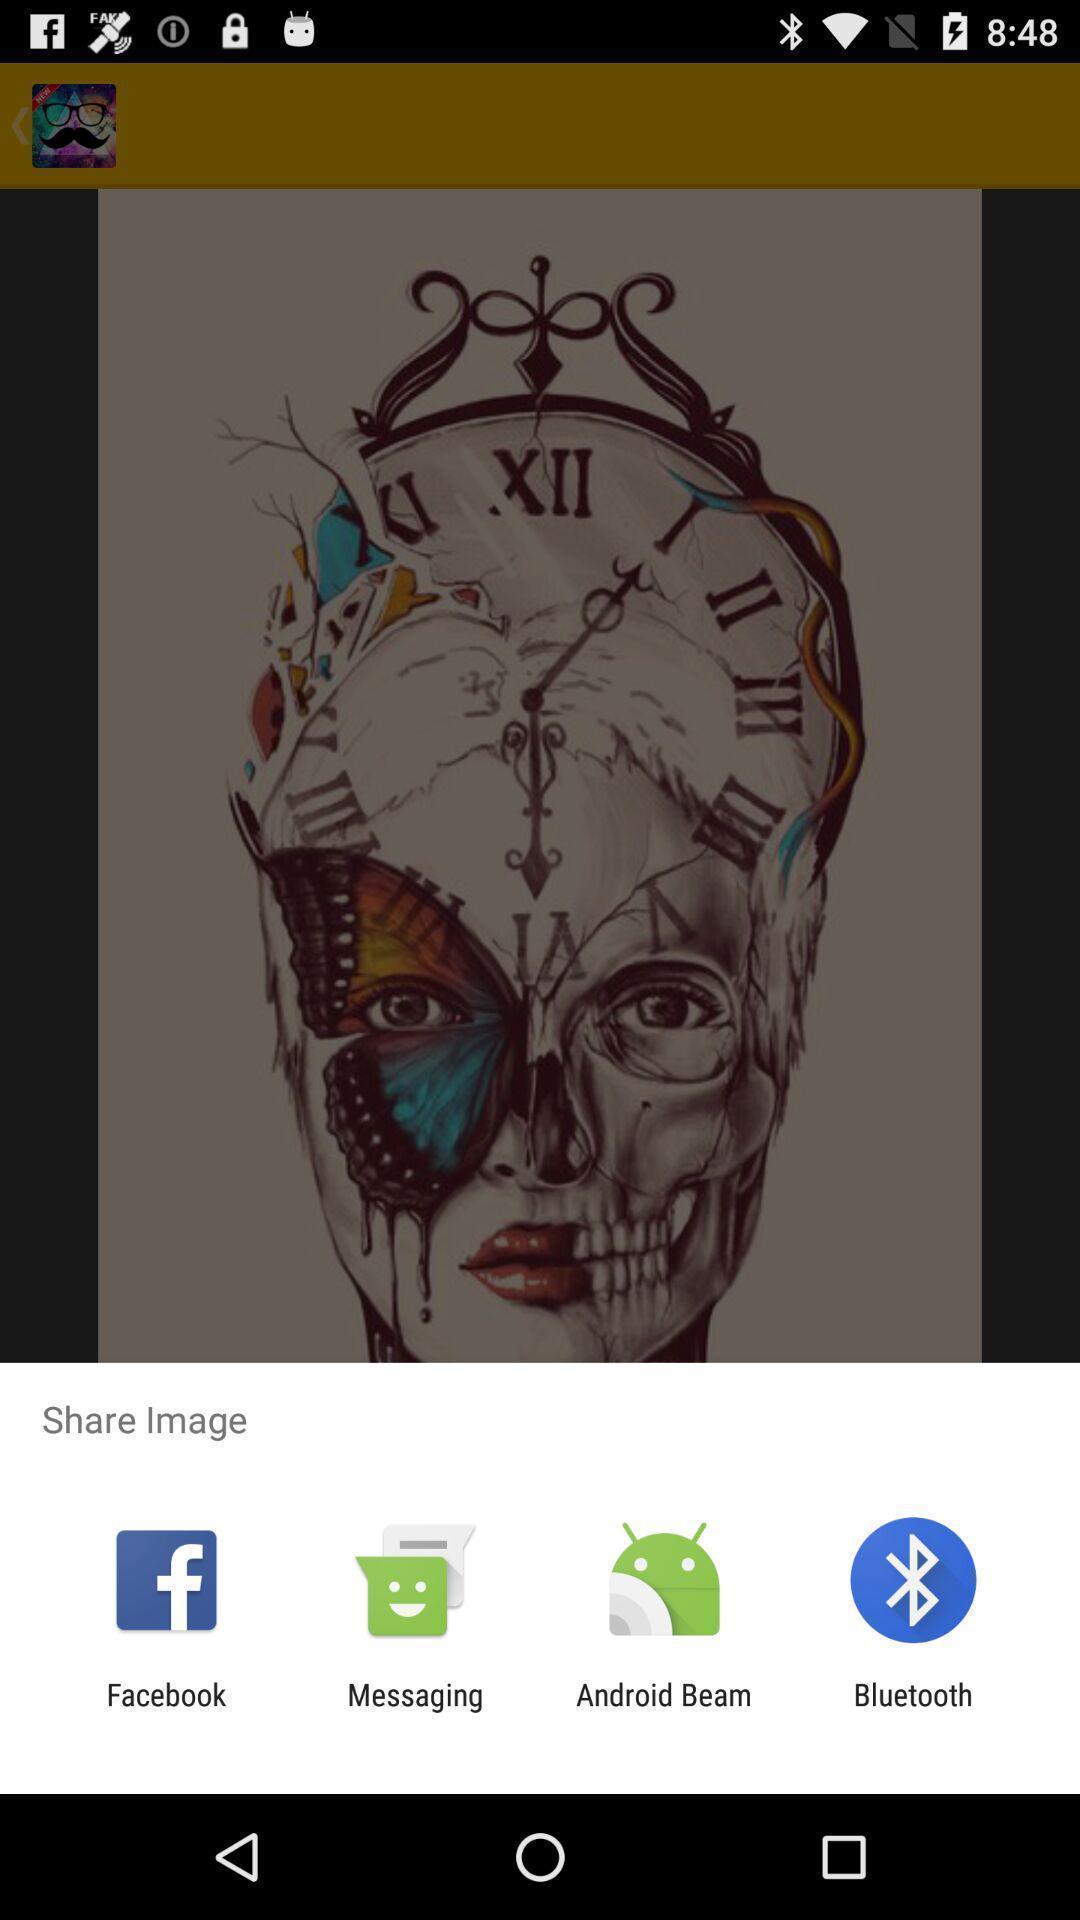Please provide a description for this image. Pop-up showing different share options. 